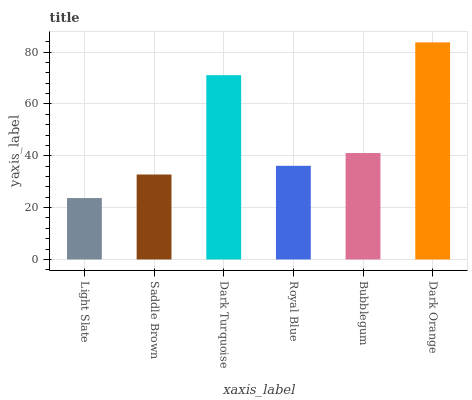Is Light Slate the minimum?
Answer yes or no. Yes. Is Dark Orange the maximum?
Answer yes or no. Yes. Is Saddle Brown the minimum?
Answer yes or no. No. Is Saddle Brown the maximum?
Answer yes or no. No. Is Saddle Brown greater than Light Slate?
Answer yes or no. Yes. Is Light Slate less than Saddle Brown?
Answer yes or no. Yes. Is Light Slate greater than Saddle Brown?
Answer yes or no. No. Is Saddle Brown less than Light Slate?
Answer yes or no. No. Is Bubblegum the high median?
Answer yes or no. Yes. Is Royal Blue the low median?
Answer yes or no. Yes. Is Saddle Brown the high median?
Answer yes or no. No. Is Saddle Brown the low median?
Answer yes or no. No. 